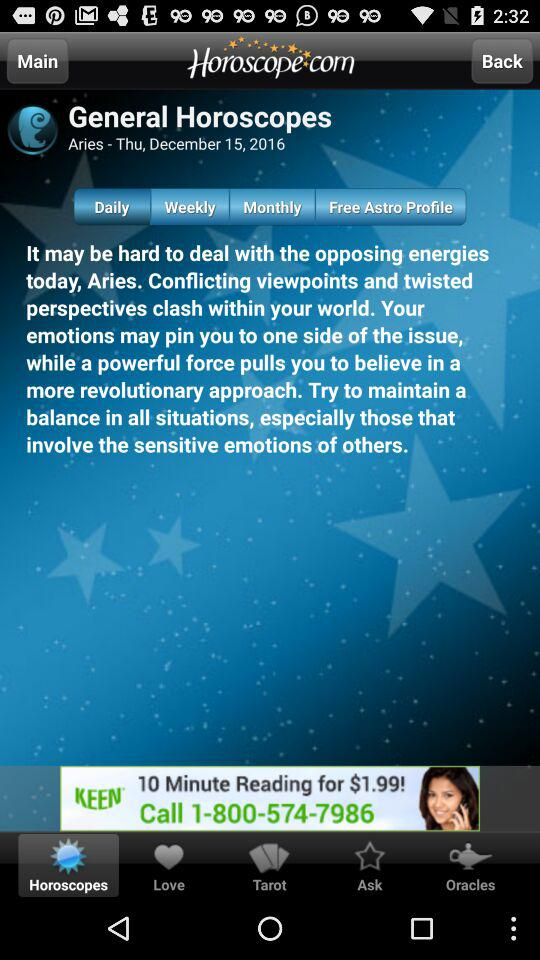What is the horoscope? The horoscope is, "It may be hard to deal with the opposing energies today, Aries. Conflicting viewpoints and twisted perspectives clash within your world. Your emotions may pin you to one side of the issue, while a powerful force pulls you to believe in a more revolutionary approach. Try to maintain a balance in all situations, especially those that involve the sensitive emotions of others.". 